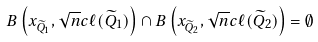Convert formula to latex. <formula><loc_0><loc_0><loc_500><loc_500>B \left ( x _ { \widetilde { Q } _ { 1 } } , \sqrt { n } c \ell ( \widetilde { Q } _ { 1 } ) \right ) \cap B \left ( x _ { \widetilde { Q } _ { 2 } } , \sqrt { n } c \ell ( \widetilde { Q } _ { 2 } ) \right ) = \emptyset</formula> 